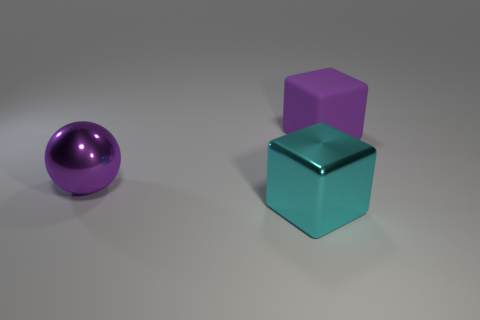Add 2 big yellow shiny things. How many objects exist? 5 Subtract all purple cubes. How many cubes are left? 1 Subtract all balls. How many objects are left? 2 Subtract 1 cubes. How many cubes are left? 1 Add 3 big purple objects. How many big purple objects exist? 5 Subtract 1 cyan cubes. How many objects are left? 2 Subtract all gray balls. Subtract all brown cylinders. How many balls are left? 1 Subtract all red cylinders. How many purple cubes are left? 1 Subtract all purple metal objects. Subtract all large purple metallic objects. How many objects are left? 1 Add 1 cyan metallic cubes. How many cyan metallic cubes are left? 2 